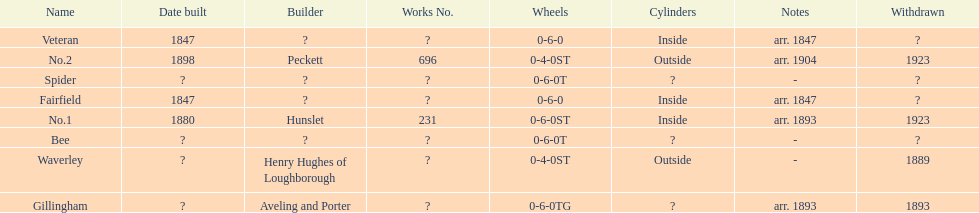How many were built in 1847? 2. 